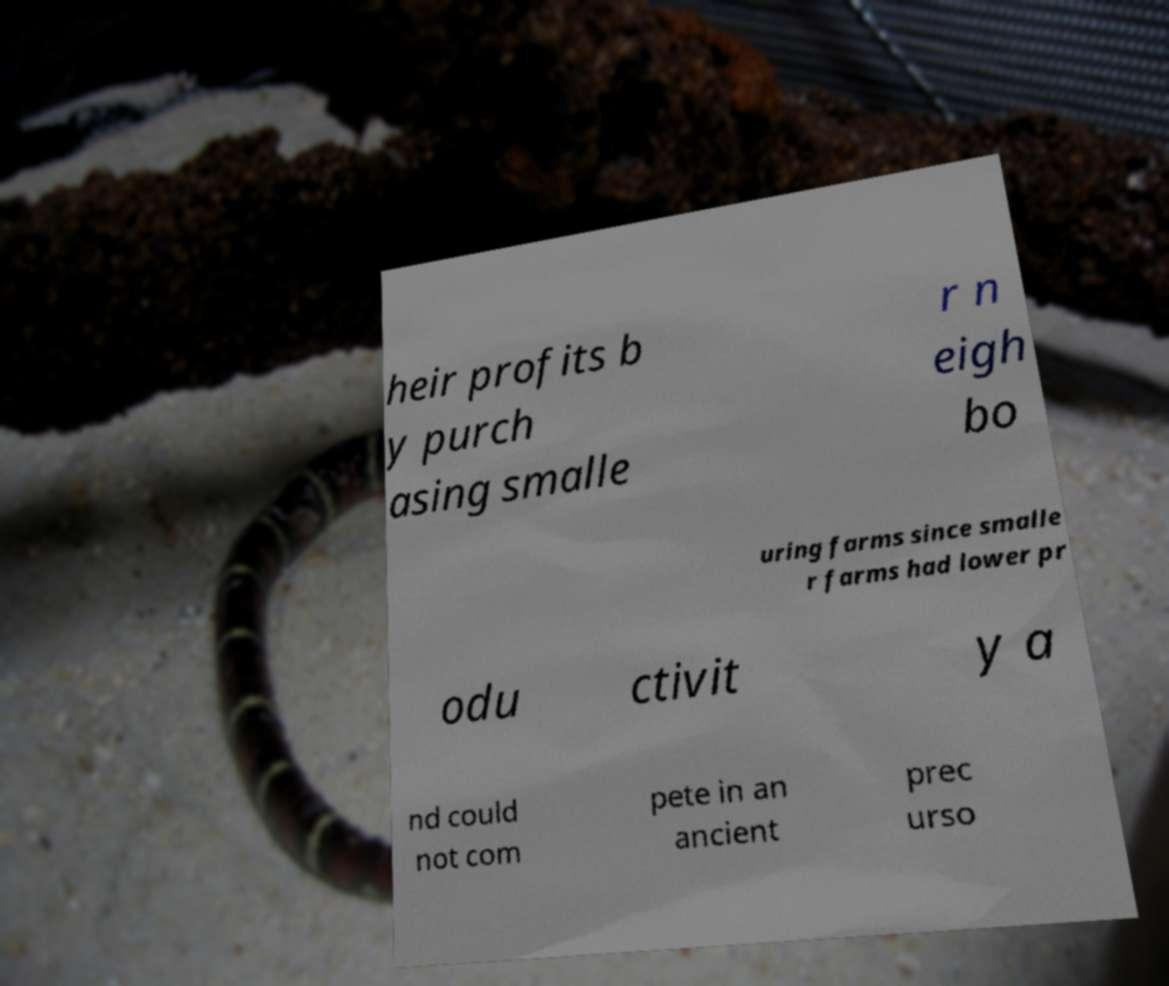Please read and relay the text visible in this image. What does it say? heir profits b y purch asing smalle r n eigh bo uring farms since smalle r farms had lower pr odu ctivit y a nd could not com pete in an ancient prec urso 